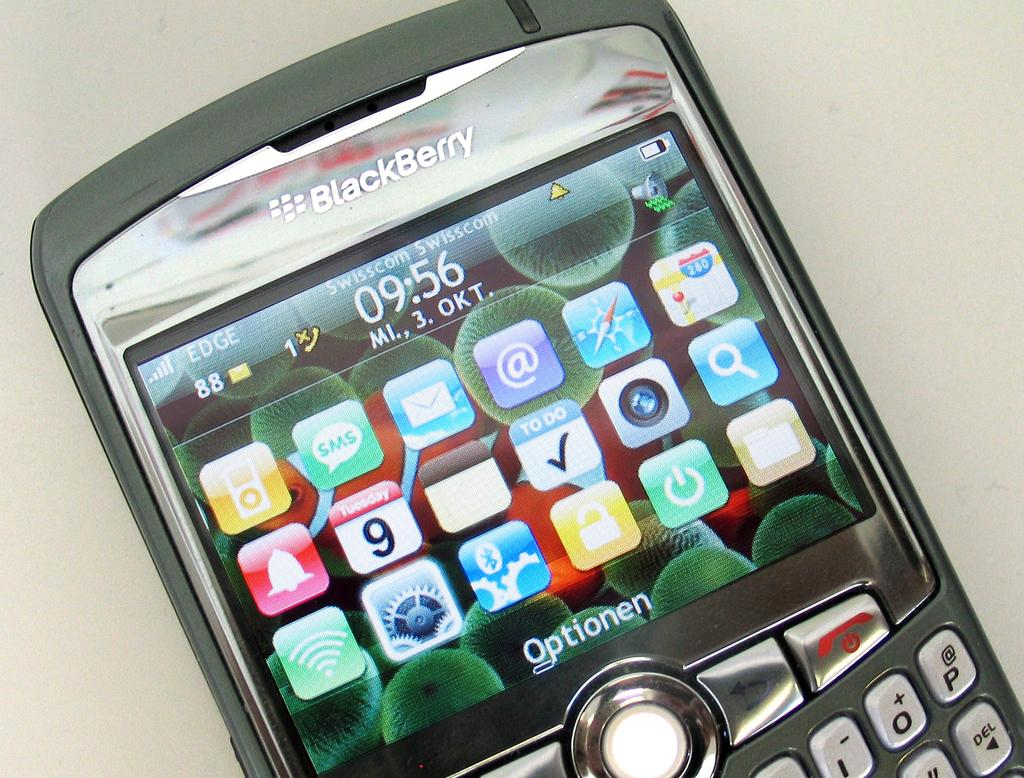What object is the main focus of the image? There is a mobile in the image. What feature does the mobile have? The mobile has buttons. What can be seen on the mobile's screen? There are applications and text visible on the mobile's screen. What information is displayed at the top of the mobile's screen? There is a name at the top of the mobile's screen. What type of society is depicted in the image? There is no society depicted in the image; it features a mobile with buttons, applications, text, and a name on the screen. What question is being asked on the mobile's screen? There is no question visible on the mobile's screen in the image. 